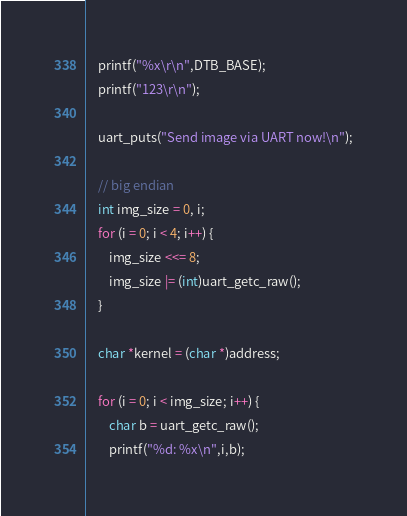Convert code to text. <code><loc_0><loc_0><loc_500><loc_500><_C_>    printf("%x\r\n",DTB_BASE);
    printf("123\r\n");

    uart_puts("Send image via UART now!\n");

    // big endian
    int img_size = 0, i;
    for (i = 0; i < 4; i++) {
        img_size <<= 8;
        img_size |= (int)uart_getc_raw();
    }

    char *kernel = (char *)address;

    for (i = 0; i < img_size; i++) {
        char b = uart_getc_raw();
        printf("%d: %x\n",i,b);</code> 